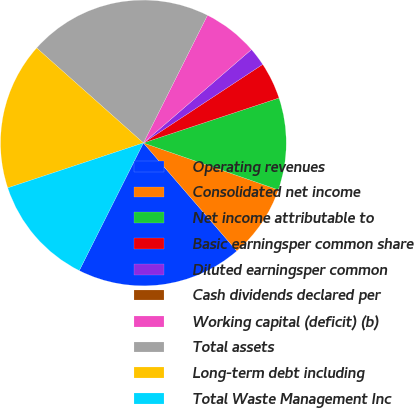Convert chart to OTSL. <chart><loc_0><loc_0><loc_500><loc_500><pie_chart><fcel>Operating revenues<fcel>Consolidated net income<fcel>Net income attributable to<fcel>Basic earningsper common share<fcel>Diluted earningsper common<fcel>Cash dividends declared per<fcel>Working capital (deficit) (b)<fcel>Total assets<fcel>Long-term debt including<fcel>Total Waste Management Inc<nl><fcel>18.75%<fcel>8.33%<fcel>10.42%<fcel>4.17%<fcel>2.08%<fcel>0.0%<fcel>6.25%<fcel>20.83%<fcel>16.67%<fcel>12.5%<nl></chart> 